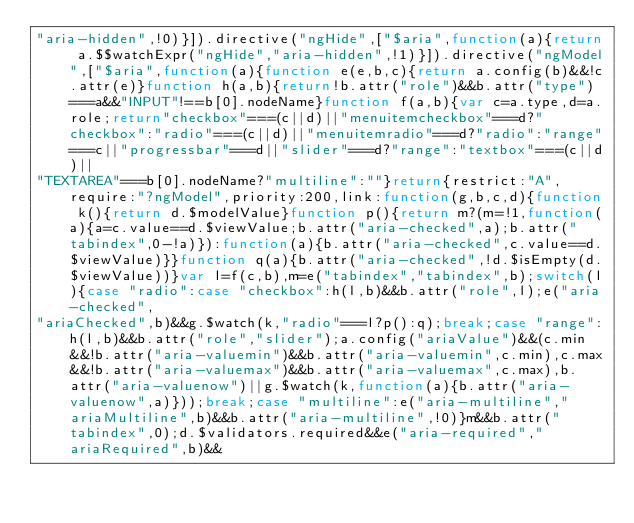Convert code to text. <code><loc_0><loc_0><loc_500><loc_500><_JavaScript_>"aria-hidden",!0)}]).directive("ngHide",["$aria",function(a){return a.$$watchExpr("ngHide","aria-hidden",!1)}]).directive("ngModel",["$aria",function(a){function e(e,b,c){return a.config(b)&&!c.attr(e)}function h(a,b){return!b.attr("role")&&b.attr("type")===a&&"INPUT"!==b[0].nodeName}function f(a,b){var c=a.type,d=a.role;return"checkbox"===(c||d)||"menuitemcheckbox"===d?"checkbox":"radio"===(c||d)||"menuitemradio"===d?"radio":"range"===c||"progressbar"===d||"slider"===d?"range":"textbox"===(c||d)||
"TEXTAREA"===b[0].nodeName?"multiline":""}return{restrict:"A",require:"?ngModel",priority:200,link:function(g,b,c,d){function k(){return d.$modelValue}function p(){return m?(m=!1,function(a){a=c.value==d.$viewValue;b.attr("aria-checked",a);b.attr("tabindex",0-!a)}):function(a){b.attr("aria-checked",c.value==d.$viewValue)}}function q(a){b.attr("aria-checked",!d.$isEmpty(d.$viewValue))}var l=f(c,b),m=e("tabindex","tabindex",b);switch(l){case "radio":case "checkbox":h(l,b)&&b.attr("role",l);e("aria-checked",
"ariaChecked",b)&&g.$watch(k,"radio"===l?p():q);break;case "range":h(l,b)&&b.attr("role","slider");a.config("ariaValue")&&(c.min&&!b.attr("aria-valuemin")&&b.attr("aria-valuemin",c.min),c.max&&!b.attr("aria-valuemax")&&b.attr("aria-valuemax",c.max),b.attr("aria-valuenow")||g.$watch(k,function(a){b.attr("aria-valuenow",a)}));break;case "multiline":e("aria-multiline","ariaMultiline",b)&&b.attr("aria-multiline",!0)}m&&b.attr("tabindex",0);d.$validators.required&&e("aria-required","ariaRequired",b)&&</code> 